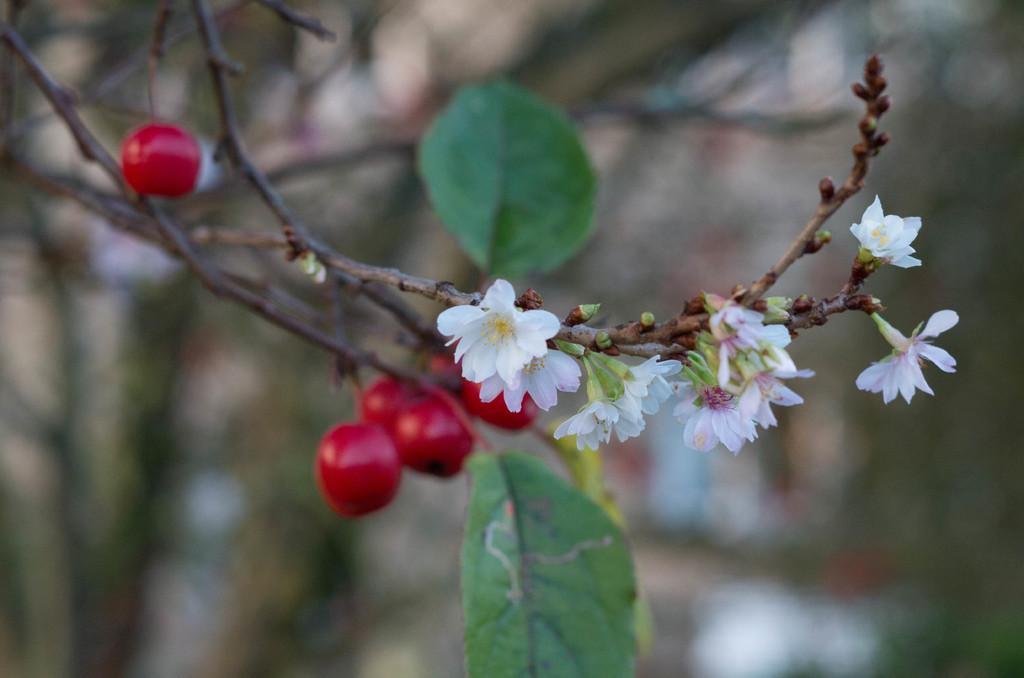How would you summarize this image in a sentence or two? In this image I can see there are red color fruits and white color flowers to this tree. In the middle there are green leaves. 